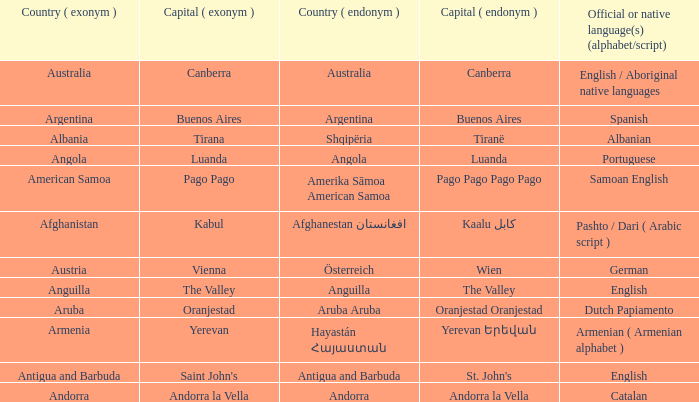What is the local name given to the capital of Anguilla? The Valley. 